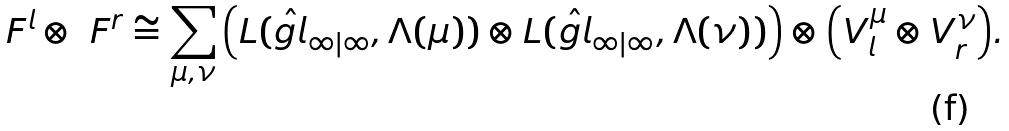Convert formula to latex. <formula><loc_0><loc_0><loc_500><loc_500>\ F ^ { l } \otimes \ F ^ { r } \cong \sum _ { \mu , \nu } \Big { ( } L ( \hat { g l } _ { \infty | \infty } , \Lambda ( \mu ) ) \otimes L ( \hat { g l } _ { \infty | \infty } , \Lambda ( \nu ) ) \Big { ) } \otimes \Big { ( } V _ { l } ^ { \mu } \otimes V _ { r } ^ { \nu } \Big { ) } .</formula> 